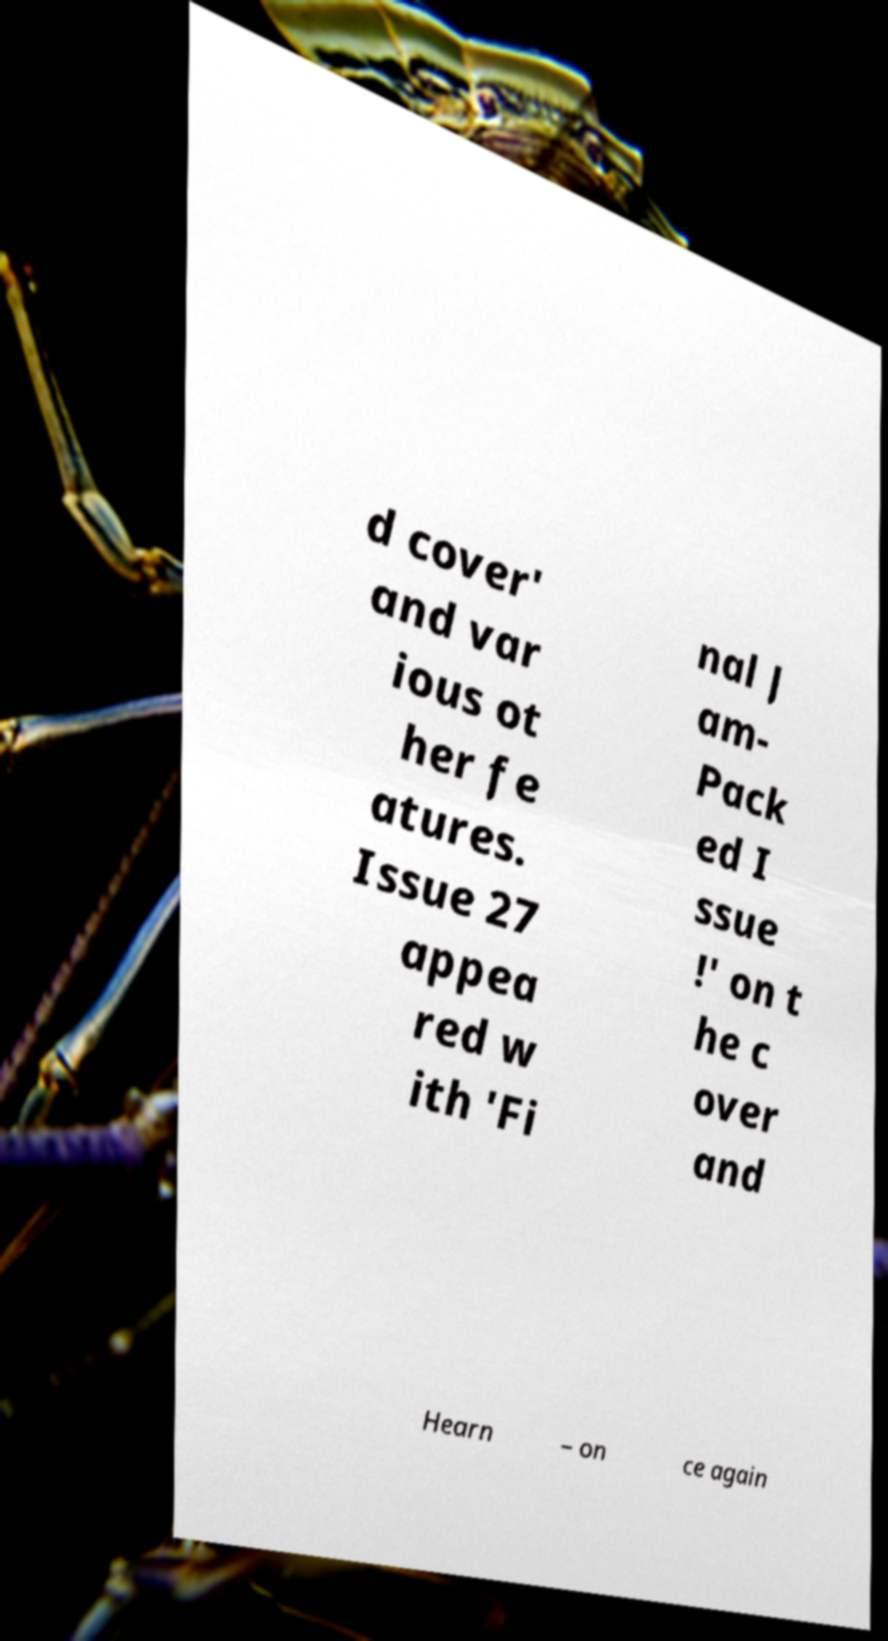I need the written content from this picture converted into text. Can you do that? d cover' and var ious ot her fe atures. Issue 27 appea red w ith 'Fi nal J am- Pack ed I ssue !' on t he c over and Hearn – on ce again 